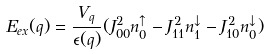<formula> <loc_0><loc_0><loc_500><loc_500>E _ { e x } ( q ) = \frac { V _ { q } } { \epsilon ( q ) } ( J _ { 0 0 } ^ { 2 } n _ { 0 } ^ { \uparrow } - J _ { 1 1 } ^ { 2 } n _ { 1 } ^ { \downarrow } - J _ { 1 0 } ^ { 2 } n _ { 0 } ^ { \downarrow } )</formula> 